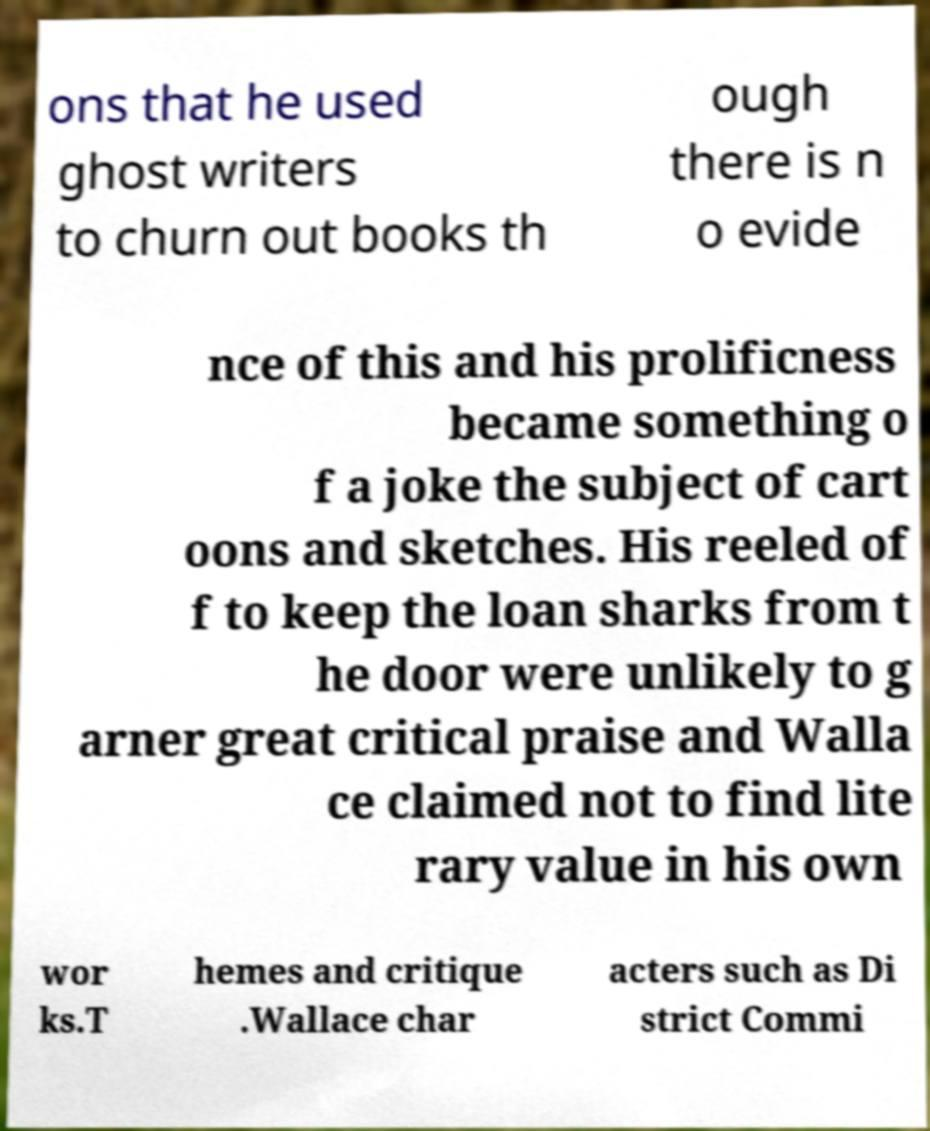Could you assist in decoding the text presented in this image and type it out clearly? ons that he used ghost writers to churn out books th ough there is n o evide nce of this and his prolificness became something o f a joke the subject of cart oons and sketches. His reeled of f to keep the loan sharks from t he door were unlikely to g arner great critical praise and Walla ce claimed not to find lite rary value in his own wor ks.T hemes and critique .Wallace char acters such as Di strict Commi 